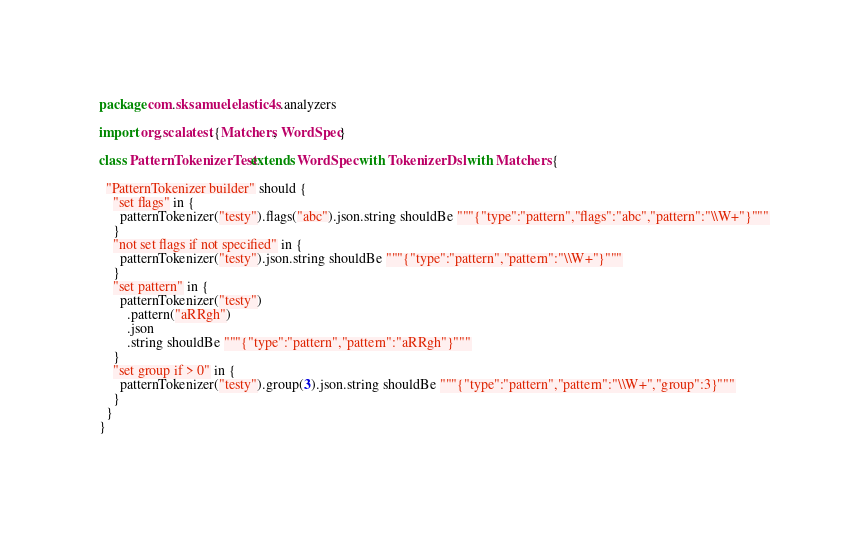Convert code to text. <code><loc_0><loc_0><loc_500><loc_500><_Scala_>package com.sksamuel.elastic4s.analyzers

import org.scalatest.{Matchers, WordSpec}

class PatternTokenizerTest extends WordSpec with TokenizerDsl with Matchers {

  "PatternTokenizer builder" should {
    "set flags" in {
      patternTokenizer("testy").flags("abc").json.string shouldBe """{"type":"pattern","flags":"abc","pattern":"\\W+"}"""
    }
    "not set flags if not specified" in {
      patternTokenizer("testy").json.string shouldBe """{"type":"pattern","pattern":"\\W+"}"""
    }
    "set pattern" in {
      patternTokenizer("testy")
        .pattern("aRRgh")
        .json
        .string shouldBe """{"type":"pattern","pattern":"aRRgh"}"""
    }
    "set group if > 0" in {
      patternTokenizer("testy").group(3).json.string shouldBe """{"type":"pattern","pattern":"\\W+","group":3}"""
    }
  }
}
</code> 